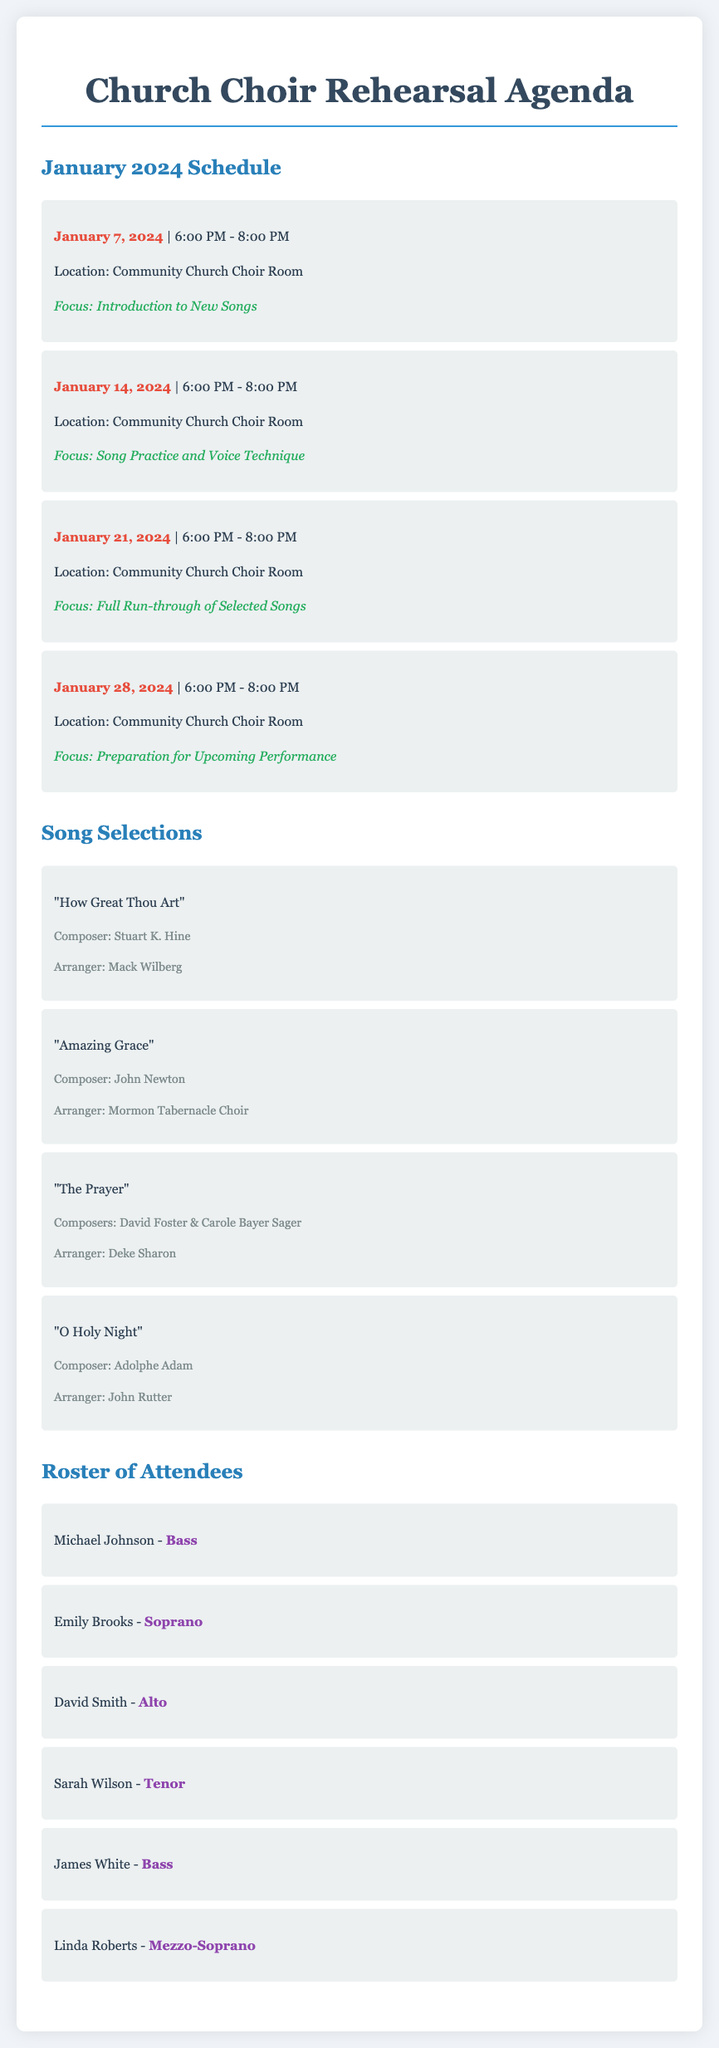What date is the first rehearsal? The first rehearsal is scheduled for January 7, 2024.
Answer: January 7, 2024 What is the focus of the rehearsal on January 21, 2024? The focus of this rehearsal is a full run-through of selected songs.
Answer: Full Run-through of Selected Songs Who is the composer of "Amazing Grace"? The document lists John Newton as the composer of "Amazing Grace".
Answer: John Newton How many rehearsals are planned for January 2024? The document outlines four rehearsals in January 2024.
Answer: Four Which song is arranged by John Rutter? The song "O Holy Night" is arranged by John Rutter.
Answer: O Holy Night Who are the Bass singers in the roster? The roster includes Michael Johnson and James White as Bass singers.
Answer: Michael Johnson, James White What is the location of the choir rehearsals? The location specified for the choir rehearsals is the Community Church Choir Room.
Answer: Community Church Choir Room What is the start time for rehearsals? Rehearsals start at 6:00 PM according to the schedule.
Answer: 6:00 PM 